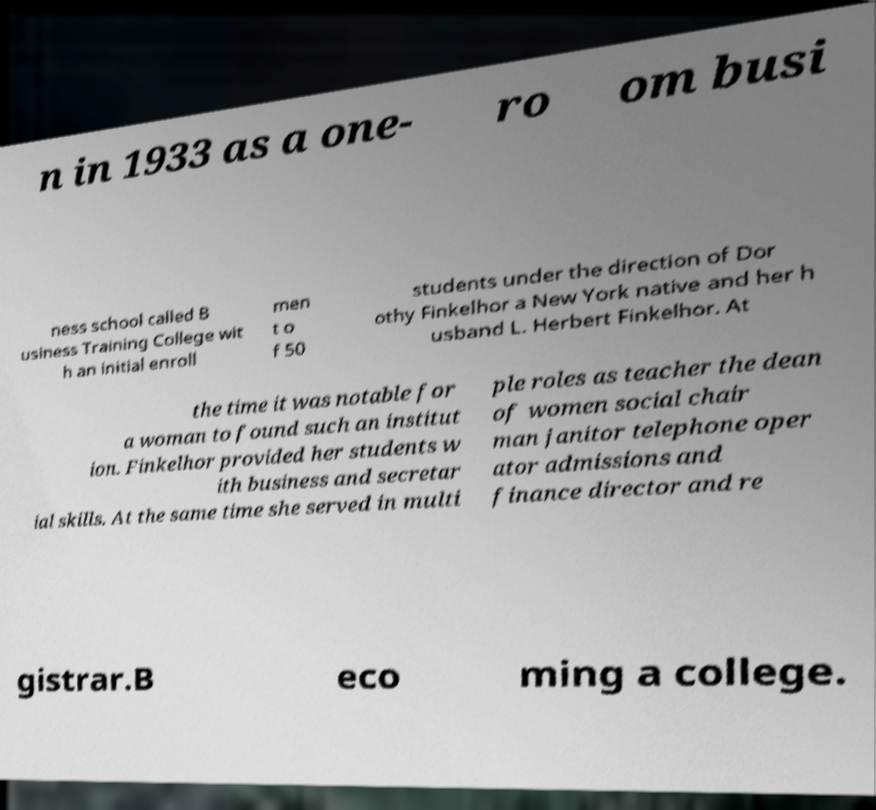I need the written content from this picture converted into text. Can you do that? n in 1933 as a one- ro om busi ness school called B usiness Training College wit h an initial enroll men t o f 50 students under the direction of Dor othy Finkelhor a New York native and her h usband L. Herbert Finkelhor. At the time it was notable for a woman to found such an institut ion. Finkelhor provided her students w ith business and secretar ial skills. At the same time she served in multi ple roles as teacher the dean of women social chair man janitor telephone oper ator admissions and finance director and re gistrar.B eco ming a college. 